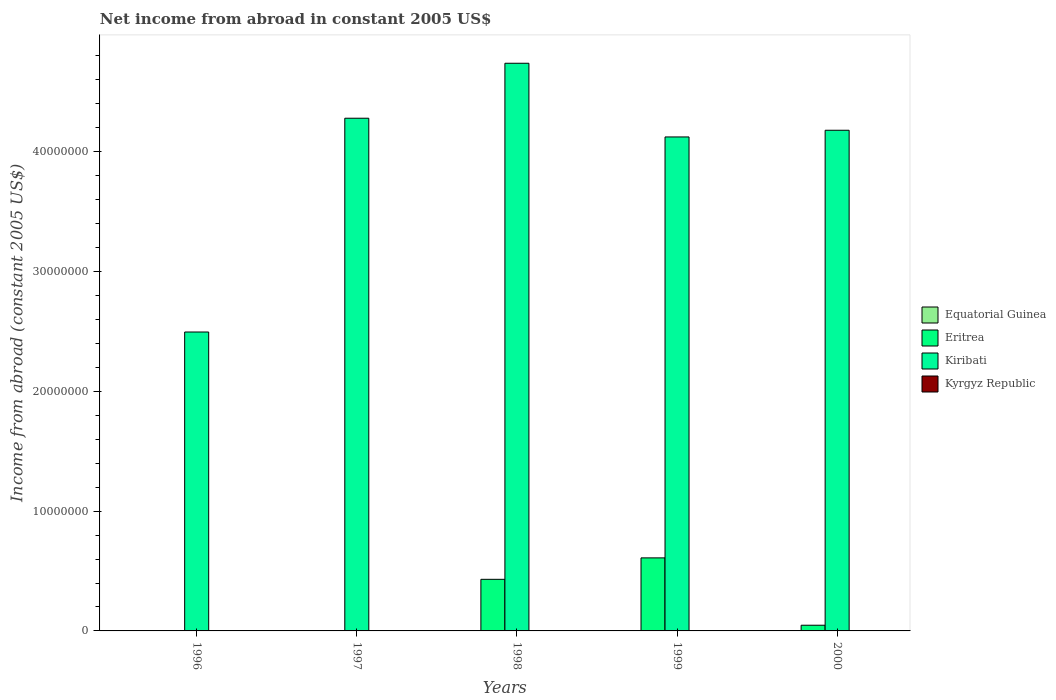Are the number of bars on each tick of the X-axis equal?
Offer a very short reply. No. What is the label of the 2nd group of bars from the left?
Ensure brevity in your answer.  1997. What is the net income from abroad in Kyrgyz Republic in 1998?
Your response must be concise. 0. Across all years, what is the maximum net income from abroad in Kiribati?
Offer a terse response. 4.74e+07. Across all years, what is the minimum net income from abroad in Eritrea?
Provide a short and direct response. 0. What is the total net income from abroad in Kyrgyz Republic in the graph?
Your answer should be very brief. 0. What is the difference between the net income from abroad in Kiribati in 1996 and that in 2000?
Make the answer very short. -1.68e+07. What is the difference between the net income from abroad in Equatorial Guinea in 2000 and the net income from abroad in Eritrea in 1999?
Ensure brevity in your answer.  -6.10e+06. What is the average net income from abroad in Equatorial Guinea per year?
Your response must be concise. 0. What is the ratio of the net income from abroad in Kiribati in 1997 to that in 1999?
Ensure brevity in your answer.  1.04. What is the difference between the highest and the second highest net income from abroad in Eritrea?
Ensure brevity in your answer.  1.79e+06. What is the difference between the highest and the lowest net income from abroad in Eritrea?
Ensure brevity in your answer.  6.10e+06. Is the sum of the net income from abroad in Kiribati in 1996 and 1998 greater than the maximum net income from abroad in Equatorial Guinea across all years?
Ensure brevity in your answer.  Yes. Is it the case that in every year, the sum of the net income from abroad in Equatorial Guinea and net income from abroad in Kiribati is greater than the sum of net income from abroad in Eritrea and net income from abroad in Kyrgyz Republic?
Provide a short and direct response. Yes. Are all the bars in the graph horizontal?
Make the answer very short. No. Does the graph contain any zero values?
Keep it short and to the point. Yes. Does the graph contain grids?
Make the answer very short. No. How many legend labels are there?
Keep it short and to the point. 4. What is the title of the graph?
Make the answer very short. Net income from abroad in constant 2005 US$. What is the label or title of the X-axis?
Offer a terse response. Years. What is the label or title of the Y-axis?
Keep it short and to the point. Income from abroad (constant 2005 US$). What is the Income from abroad (constant 2005 US$) of Equatorial Guinea in 1996?
Keep it short and to the point. 0. What is the Income from abroad (constant 2005 US$) of Kiribati in 1996?
Give a very brief answer. 2.50e+07. What is the Income from abroad (constant 2005 US$) of Equatorial Guinea in 1997?
Offer a very short reply. 0. What is the Income from abroad (constant 2005 US$) in Eritrea in 1997?
Your answer should be compact. 0. What is the Income from abroad (constant 2005 US$) of Kiribati in 1997?
Your answer should be very brief. 4.28e+07. What is the Income from abroad (constant 2005 US$) of Kyrgyz Republic in 1997?
Ensure brevity in your answer.  0. What is the Income from abroad (constant 2005 US$) in Equatorial Guinea in 1998?
Provide a succinct answer. 0. What is the Income from abroad (constant 2005 US$) in Eritrea in 1998?
Provide a short and direct response. 4.31e+06. What is the Income from abroad (constant 2005 US$) of Kiribati in 1998?
Your answer should be compact. 4.74e+07. What is the Income from abroad (constant 2005 US$) in Eritrea in 1999?
Offer a terse response. 6.10e+06. What is the Income from abroad (constant 2005 US$) in Kiribati in 1999?
Ensure brevity in your answer.  4.12e+07. What is the Income from abroad (constant 2005 US$) of Equatorial Guinea in 2000?
Keep it short and to the point. 0. What is the Income from abroad (constant 2005 US$) in Eritrea in 2000?
Give a very brief answer. 4.76e+05. What is the Income from abroad (constant 2005 US$) in Kiribati in 2000?
Give a very brief answer. 4.18e+07. Across all years, what is the maximum Income from abroad (constant 2005 US$) in Eritrea?
Your answer should be compact. 6.10e+06. Across all years, what is the maximum Income from abroad (constant 2005 US$) of Kiribati?
Provide a short and direct response. 4.74e+07. Across all years, what is the minimum Income from abroad (constant 2005 US$) of Eritrea?
Provide a succinct answer. 0. Across all years, what is the minimum Income from abroad (constant 2005 US$) in Kiribati?
Your answer should be compact. 2.50e+07. What is the total Income from abroad (constant 2005 US$) of Equatorial Guinea in the graph?
Provide a short and direct response. 0. What is the total Income from abroad (constant 2005 US$) of Eritrea in the graph?
Provide a succinct answer. 1.09e+07. What is the total Income from abroad (constant 2005 US$) of Kiribati in the graph?
Your answer should be very brief. 1.98e+08. What is the total Income from abroad (constant 2005 US$) of Kyrgyz Republic in the graph?
Give a very brief answer. 0. What is the difference between the Income from abroad (constant 2005 US$) in Kiribati in 1996 and that in 1997?
Your answer should be very brief. -1.78e+07. What is the difference between the Income from abroad (constant 2005 US$) of Kiribati in 1996 and that in 1998?
Offer a terse response. -2.24e+07. What is the difference between the Income from abroad (constant 2005 US$) in Kiribati in 1996 and that in 1999?
Provide a short and direct response. -1.63e+07. What is the difference between the Income from abroad (constant 2005 US$) of Kiribati in 1996 and that in 2000?
Ensure brevity in your answer.  -1.68e+07. What is the difference between the Income from abroad (constant 2005 US$) in Kiribati in 1997 and that in 1998?
Provide a short and direct response. -4.59e+06. What is the difference between the Income from abroad (constant 2005 US$) of Kiribati in 1997 and that in 1999?
Give a very brief answer. 1.56e+06. What is the difference between the Income from abroad (constant 2005 US$) of Kiribati in 1997 and that in 2000?
Make the answer very short. 1.00e+06. What is the difference between the Income from abroad (constant 2005 US$) of Eritrea in 1998 and that in 1999?
Offer a terse response. -1.79e+06. What is the difference between the Income from abroad (constant 2005 US$) in Kiribati in 1998 and that in 1999?
Your response must be concise. 6.15e+06. What is the difference between the Income from abroad (constant 2005 US$) in Eritrea in 1998 and that in 2000?
Your response must be concise. 3.83e+06. What is the difference between the Income from abroad (constant 2005 US$) of Kiribati in 1998 and that in 2000?
Offer a terse response. 5.59e+06. What is the difference between the Income from abroad (constant 2005 US$) in Eritrea in 1999 and that in 2000?
Keep it short and to the point. 5.62e+06. What is the difference between the Income from abroad (constant 2005 US$) of Kiribati in 1999 and that in 2000?
Offer a terse response. -5.59e+05. What is the difference between the Income from abroad (constant 2005 US$) of Eritrea in 1998 and the Income from abroad (constant 2005 US$) of Kiribati in 1999?
Your answer should be compact. -3.69e+07. What is the difference between the Income from abroad (constant 2005 US$) of Eritrea in 1998 and the Income from abroad (constant 2005 US$) of Kiribati in 2000?
Your answer should be compact. -3.75e+07. What is the difference between the Income from abroad (constant 2005 US$) in Eritrea in 1999 and the Income from abroad (constant 2005 US$) in Kiribati in 2000?
Provide a succinct answer. -3.57e+07. What is the average Income from abroad (constant 2005 US$) of Eritrea per year?
Make the answer very short. 2.18e+06. What is the average Income from abroad (constant 2005 US$) in Kiribati per year?
Give a very brief answer. 3.96e+07. In the year 1998, what is the difference between the Income from abroad (constant 2005 US$) in Eritrea and Income from abroad (constant 2005 US$) in Kiribati?
Ensure brevity in your answer.  -4.31e+07. In the year 1999, what is the difference between the Income from abroad (constant 2005 US$) in Eritrea and Income from abroad (constant 2005 US$) in Kiribati?
Your answer should be very brief. -3.51e+07. In the year 2000, what is the difference between the Income from abroad (constant 2005 US$) of Eritrea and Income from abroad (constant 2005 US$) of Kiribati?
Make the answer very short. -4.13e+07. What is the ratio of the Income from abroad (constant 2005 US$) in Kiribati in 1996 to that in 1997?
Make the answer very short. 0.58. What is the ratio of the Income from abroad (constant 2005 US$) in Kiribati in 1996 to that in 1998?
Your response must be concise. 0.53. What is the ratio of the Income from abroad (constant 2005 US$) in Kiribati in 1996 to that in 1999?
Offer a very short reply. 0.61. What is the ratio of the Income from abroad (constant 2005 US$) in Kiribati in 1996 to that in 2000?
Your answer should be compact. 0.6. What is the ratio of the Income from abroad (constant 2005 US$) of Kiribati in 1997 to that in 1998?
Keep it short and to the point. 0.9. What is the ratio of the Income from abroad (constant 2005 US$) of Kiribati in 1997 to that in 1999?
Give a very brief answer. 1.04. What is the ratio of the Income from abroad (constant 2005 US$) in Eritrea in 1998 to that in 1999?
Make the answer very short. 0.71. What is the ratio of the Income from abroad (constant 2005 US$) of Kiribati in 1998 to that in 1999?
Provide a succinct answer. 1.15. What is the ratio of the Income from abroad (constant 2005 US$) of Eritrea in 1998 to that in 2000?
Your answer should be compact. 9.06. What is the ratio of the Income from abroad (constant 2005 US$) of Kiribati in 1998 to that in 2000?
Provide a succinct answer. 1.13. What is the ratio of the Income from abroad (constant 2005 US$) in Eritrea in 1999 to that in 2000?
Ensure brevity in your answer.  12.82. What is the ratio of the Income from abroad (constant 2005 US$) of Kiribati in 1999 to that in 2000?
Your answer should be very brief. 0.99. What is the difference between the highest and the second highest Income from abroad (constant 2005 US$) in Eritrea?
Offer a very short reply. 1.79e+06. What is the difference between the highest and the second highest Income from abroad (constant 2005 US$) of Kiribati?
Provide a succinct answer. 4.59e+06. What is the difference between the highest and the lowest Income from abroad (constant 2005 US$) of Eritrea?
Provide a succinct answer. 6.10e+06. What is the difference between the highest and the lowest Income from abroad (constant 2005 US$) in Kiribati?
Offer a very short reply. 2.24e+07. 